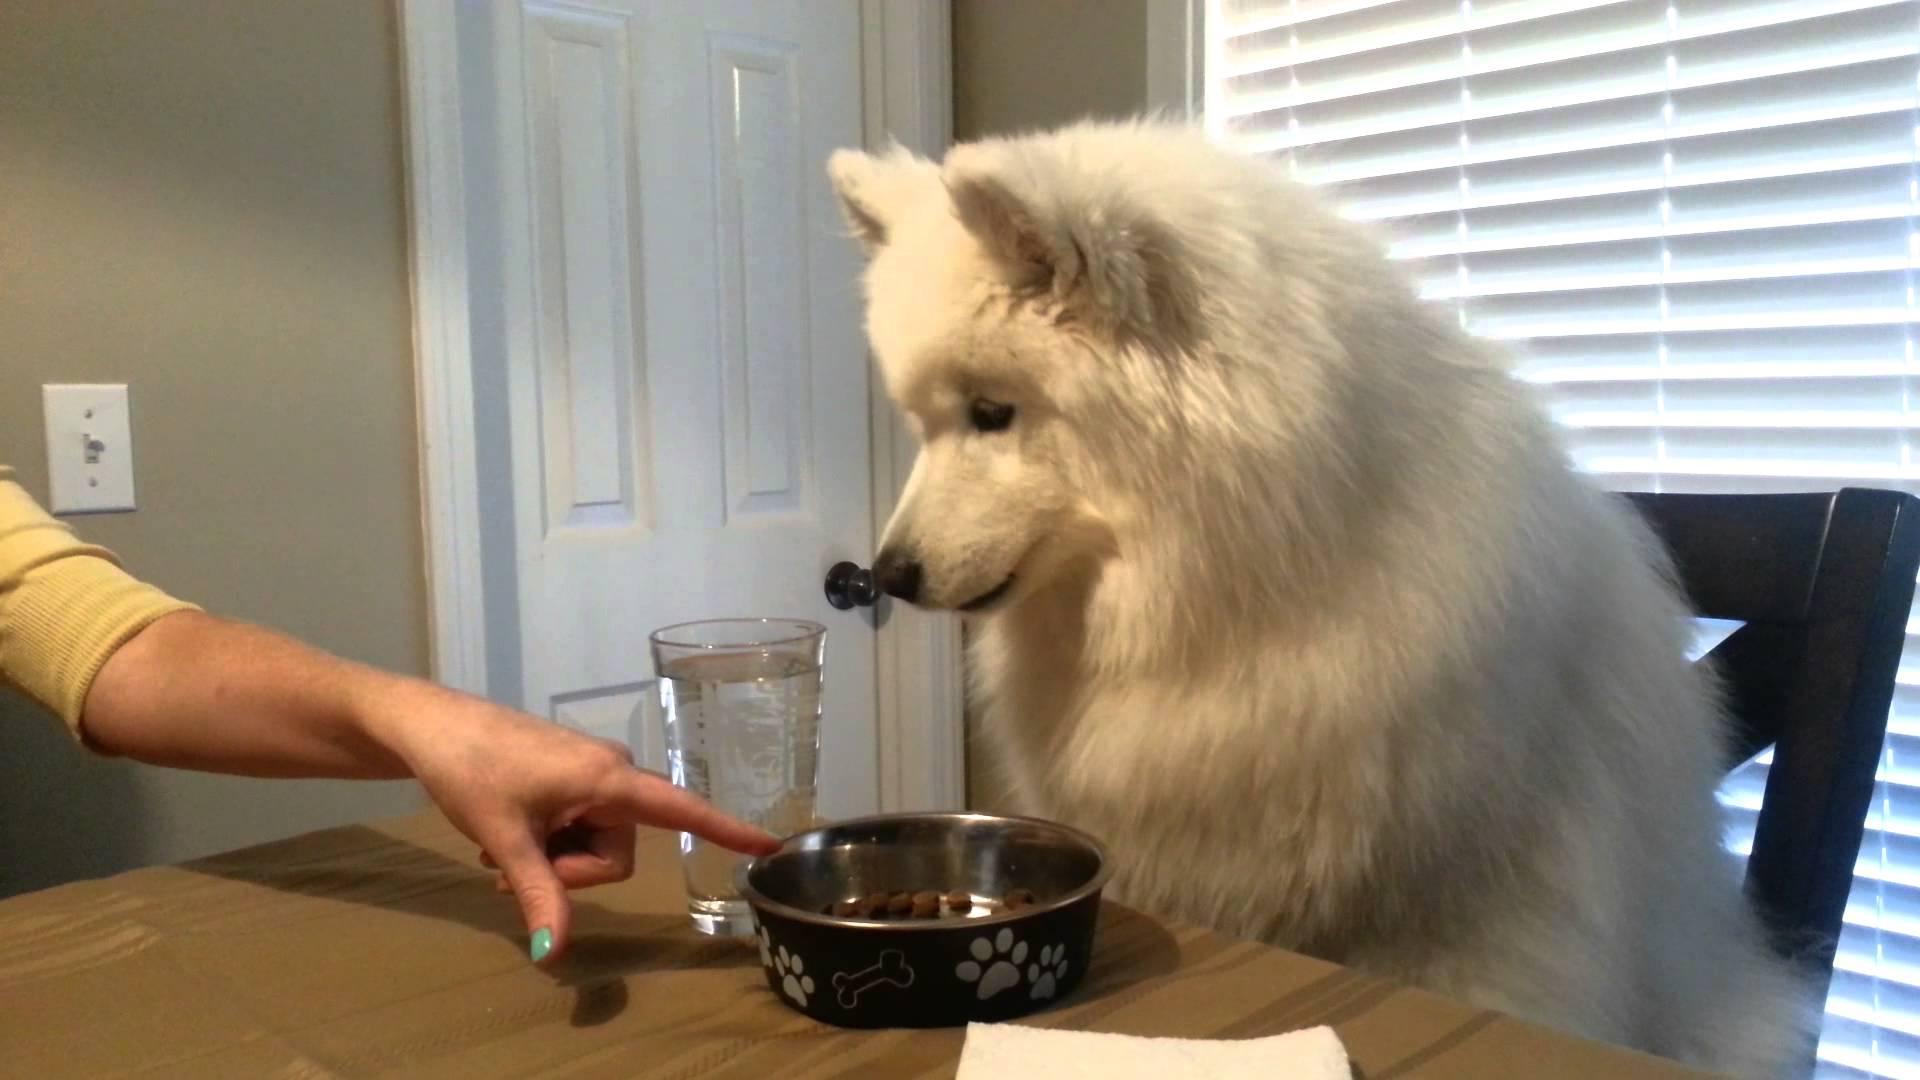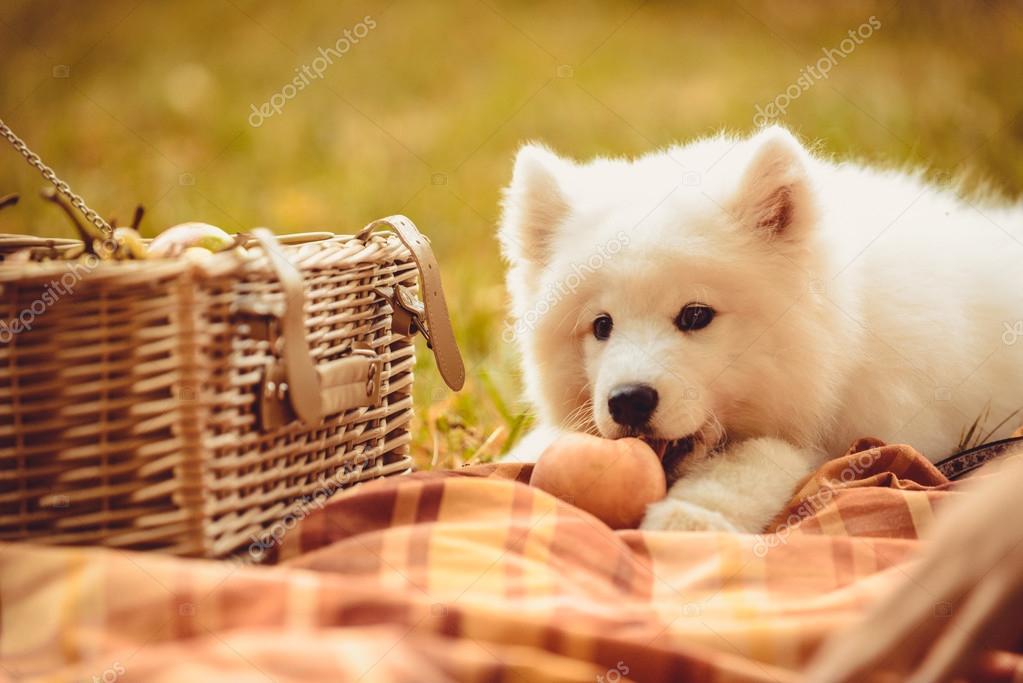The first image is the image on the left, the second image is the image on the right. Considering the images on both sides, is "The leftmost image has a dog sitting in a chair, at a table with a plate or bowl and a cup in front of them." valid? Answer yes or no. Yes. The first image is the image on the left, the second image is the image on the right. Analyze the images presented: Is the assertion "A puppy on a checkered blanket next to a picnic basket" valid? Answer yes or no. Yes. 